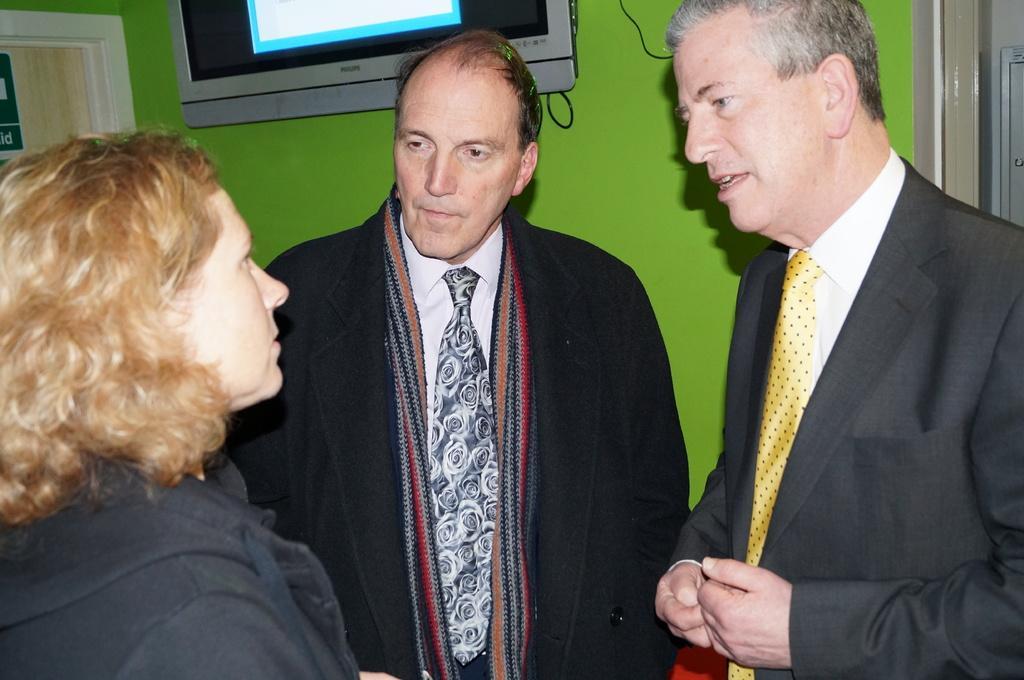How would you summarize this image in a sentence or two? In this image we can see two men and a woman standing. On the backside we can see a television, door and a wall. 